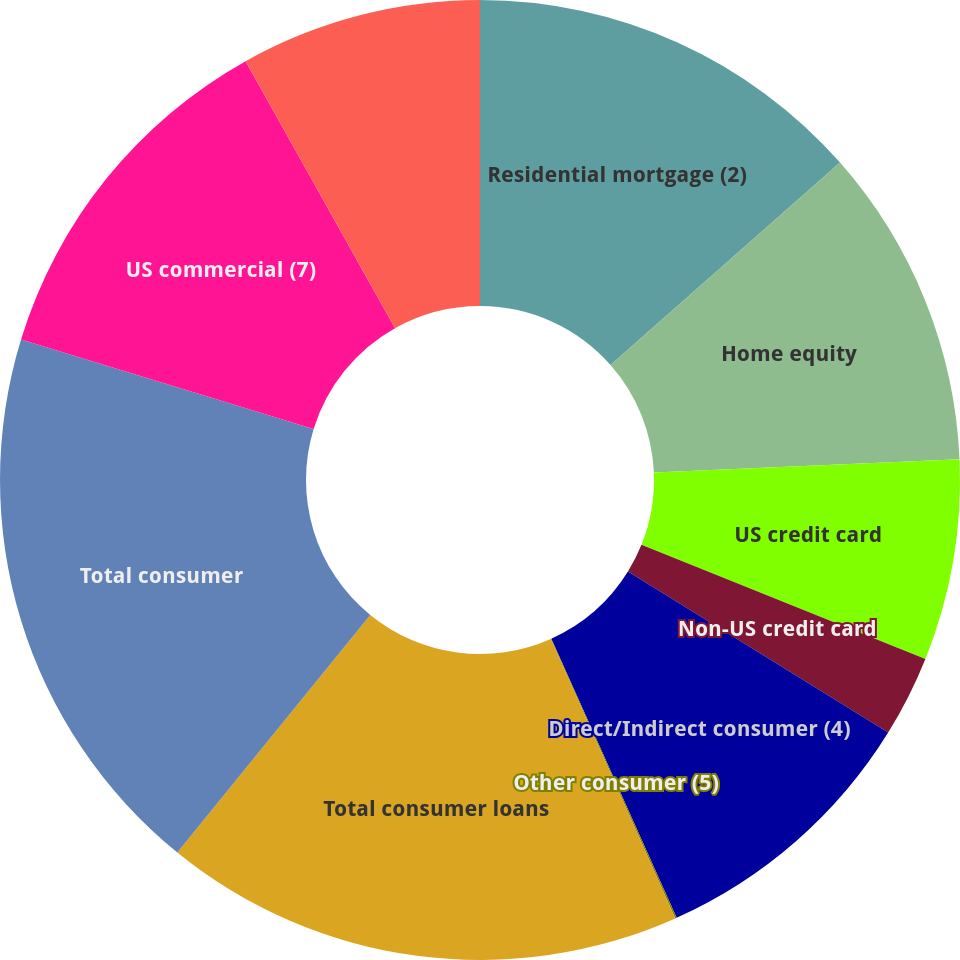<chart> <loc_0><loc_0><loc_500><loc_500><pie_chart><fcel>Residential mortgage (2)<fcel>Home equity<fcel>US credit card<fcel>Non-US credit card<fcel>Direct/Indirect consumer (4)<fcel>Other consumer (5)<fcel>Total consumer loans<fcel>Total consumer<fcel>US commercial (7)<fcel>Commercial real estate (8)<nl><fcel>13.5%<fcel>10.81%<fcel>6.77%<fcel>2.74%<fcel>9.46%<fcel>0.05%<fcel>17.53%<fcel>18.87%<fcel>12.15%<fcel>8.12%<nl></chart> 